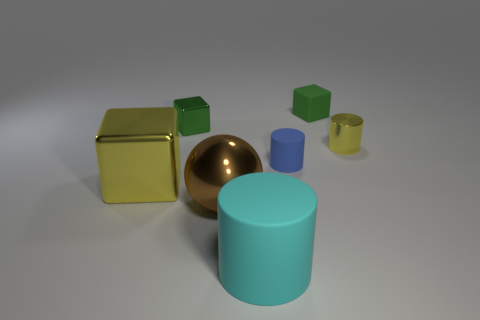Can you describe the materials the objects are made of in this image? In the image, the objects appear to have different materials. The large cube at the left, for example, has a shiny, metallic finish that could be indicative of metal. The sphere has a reflective surface similar to polished brass. The cylinders seem matte, possibly made of a plastic or ceramic material with a less reflective finish. 